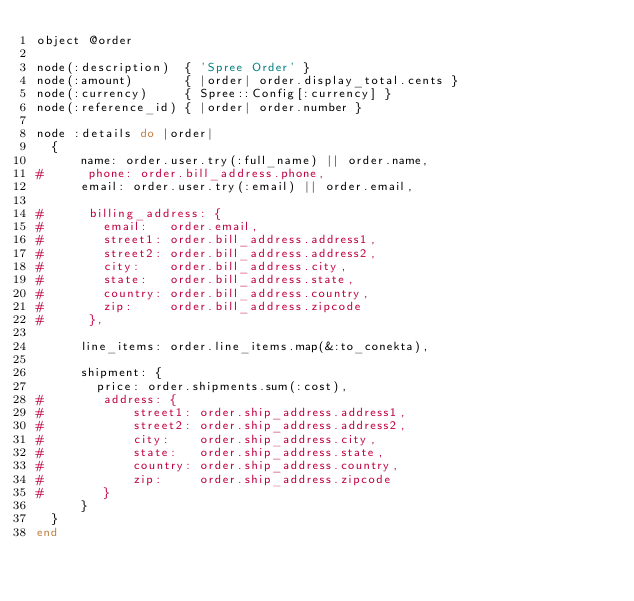Convert code to text. <code><loc_0><loc_0><loc_500><loc_500><_Ruby_>object @order

node(:description)  { 'Spree Order' }
node(:amount)       { |order| order.display_total.cents }
node(:currency)     { Spree::Config[:currency] }
node(:reference_id) { |order| order.number }

node :details do |order|
  {
      name: order.user.try(:full_name) || order.name,
#      phone: order.bill_address.phone,
      email: order.user.try(:email) || order.email,

#      billing_address: {
#        email:   order.email,
#        street1: order.bill_address.address1,
#        street2: order.bill_address.address2,
#        city:    order.bill_address.city,
#        state:   order.bill_address.state,
#        country: order.bill_address.country,
#        zip:     order.bill_address.zipcode
#      },

      line_items: order.line_items.map(&:to_conekta),

      shipment: {
        price: order.shipments.sum(:cost),
#        address: {
#            street1: order.ship_address.address1,
#            street2: order.ship_address.address2,
#            city:    order.ship_address.city,
#            state:   order.ship_address.state,
#            country: order.ship_address.country,
#            zip:     order.ship_address.zipcode
#        }
      }
  }
end
</code> 